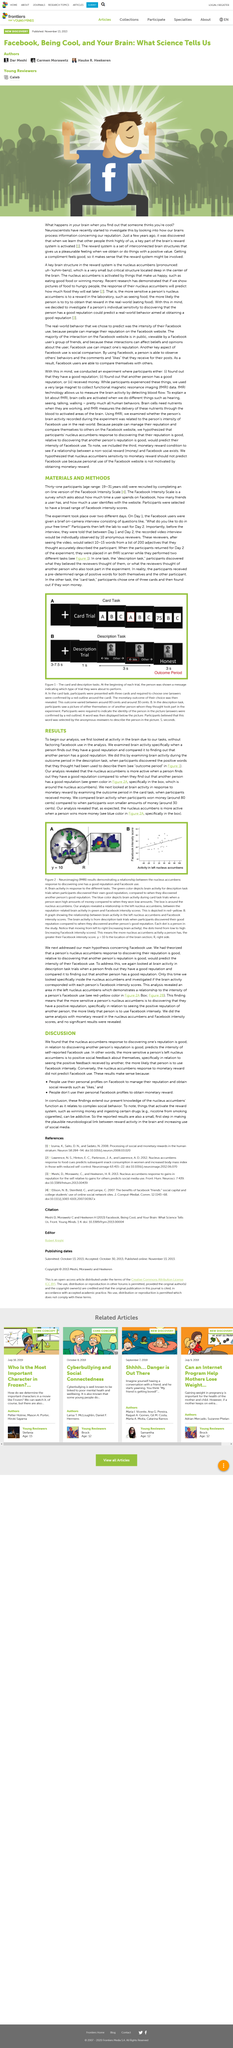Indicate a few pertinent items in this graphic. When a person learns that they have a good reputation, the nucleus accumbens in their brain becomes more active. The study found that the nucleus accumbens response to monetary reward did not predict Facebook use. The two types of tasks were card tasks and description tasks. The experiment took place over a period of two days. Facebook was the social media site used to assist with the analysis. 